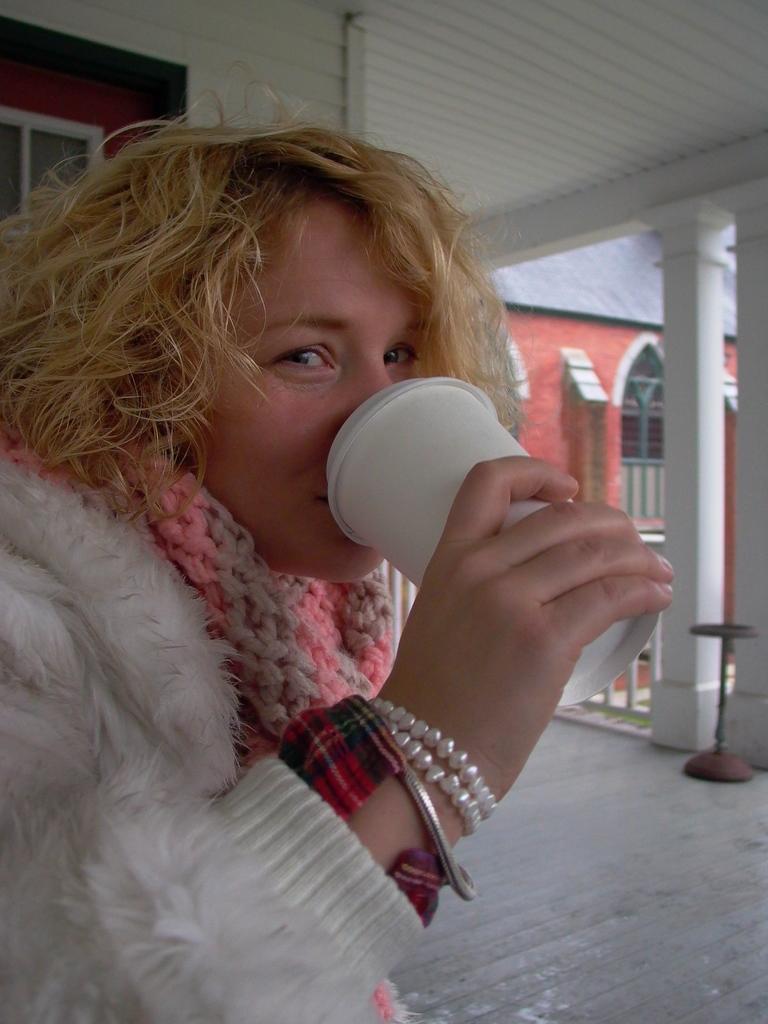How would you summarize this image in a sentence or two? This person is drinking juice from this cup. Back Side we can see pillars, windows and wall. 